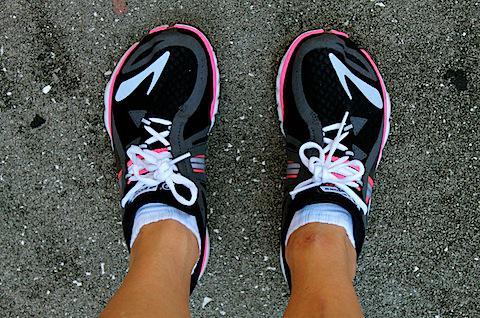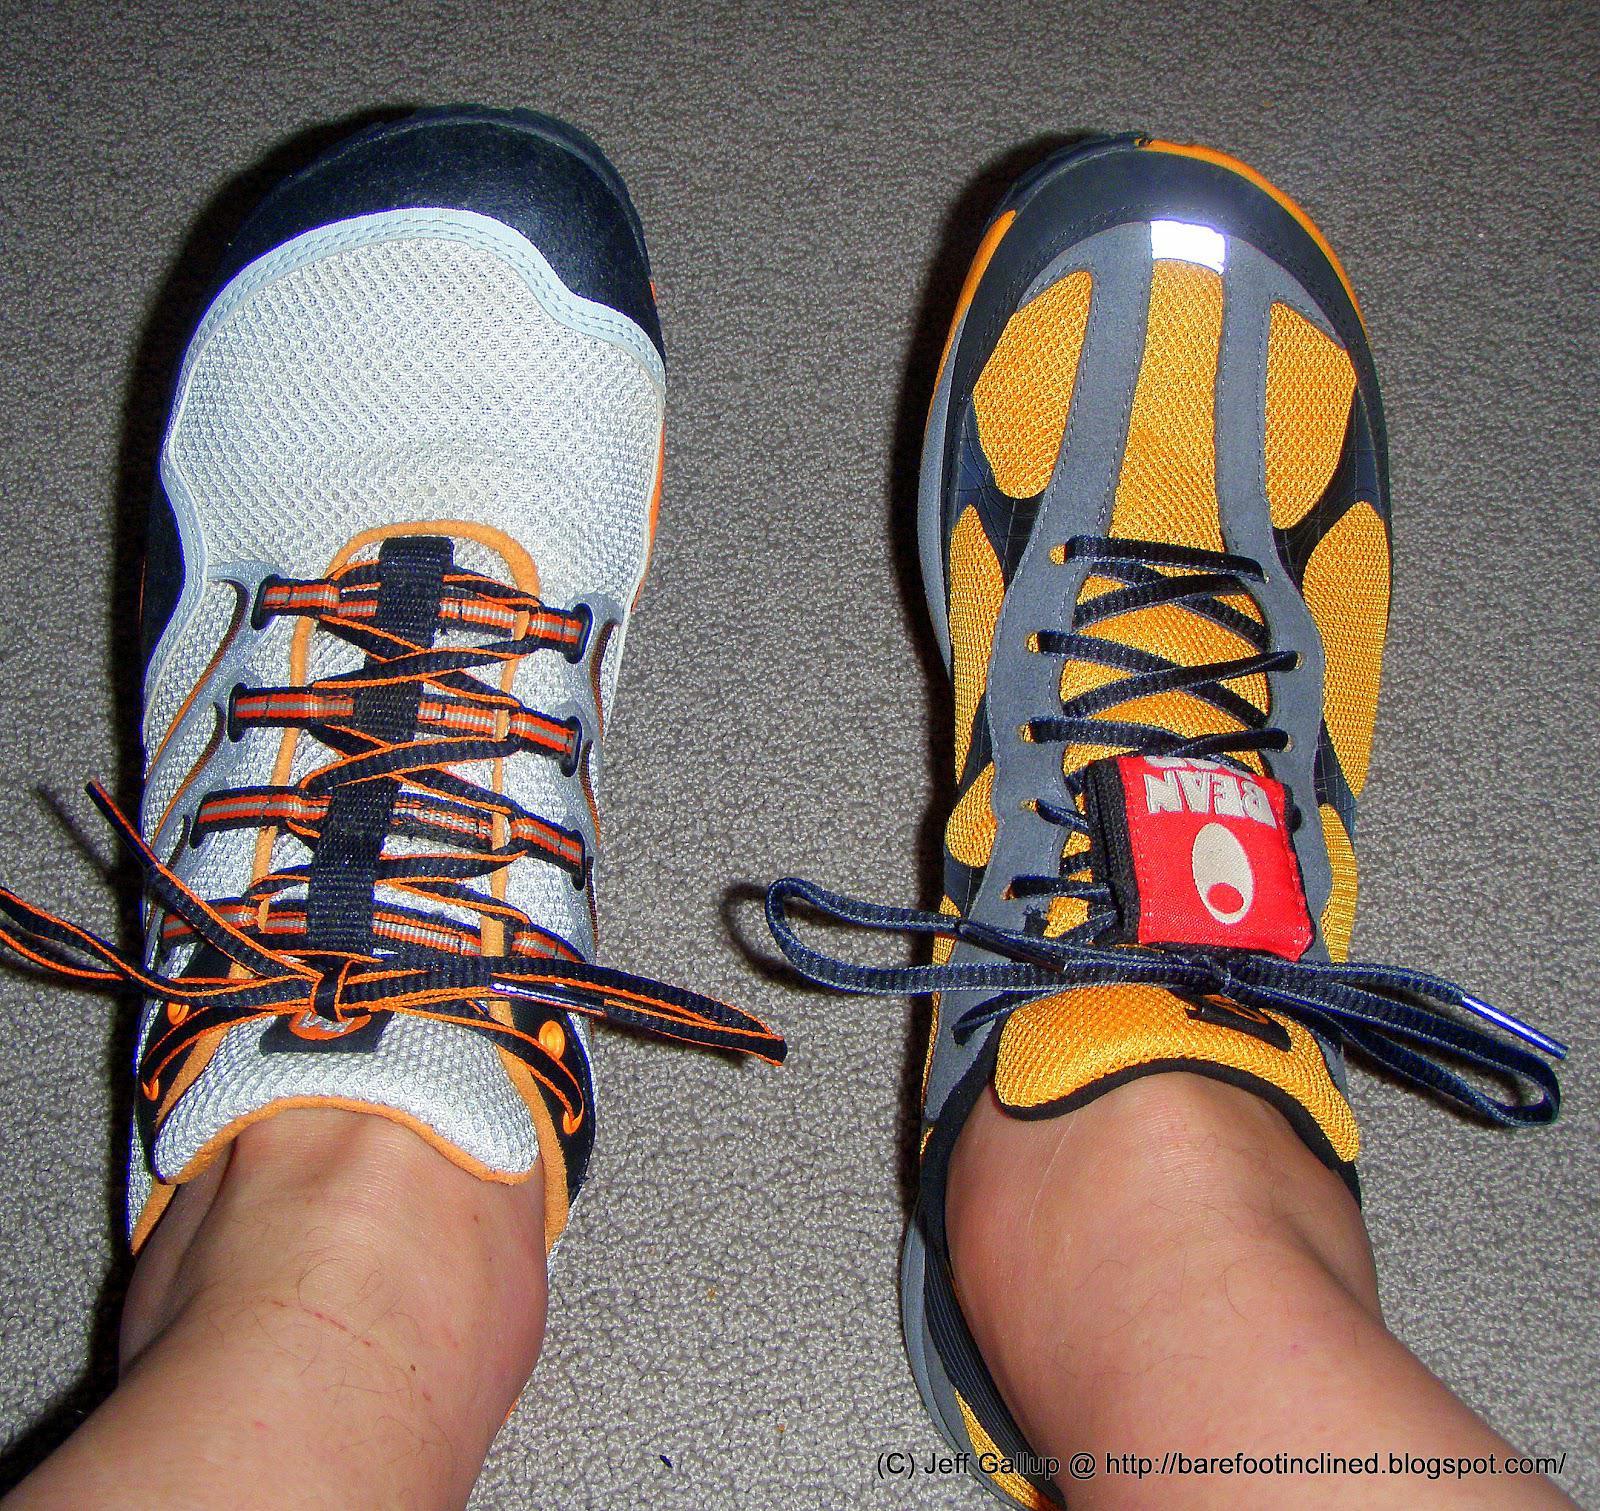The first image is the image on the left, the second image is the image on the right. Considering the images on both sides, is "One image is a top-view of human feet wearing matching sneakers with white laces." valid? Answer yes or no. Yes. The first image is the image on the left, the second image is the image on the right. For the images displayed, is the sentence "At least one image shows a pair of running shoes that are being worn on a person's feet" factually correct? Answer yes or no. Yes. 